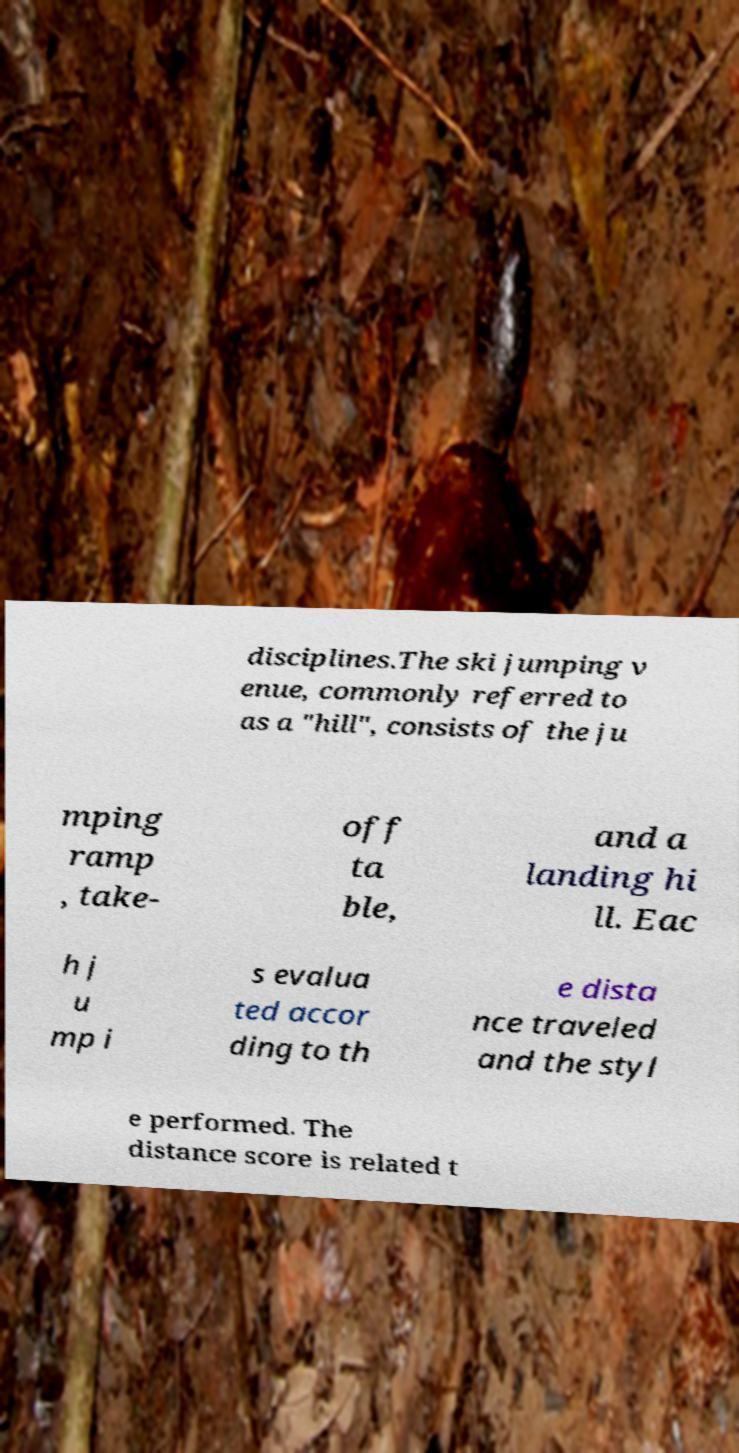Could you extract and type out the text from this image? disciplines.The ski jumping v enue, commonly referred to as a "hill", consists of the ju mping ramp , take- off ta ble, and a landing hi ll. Eac h j u mp i s evalua ted accor ding to th e dista nce traveled and the styl e performed. The distance score is related t 